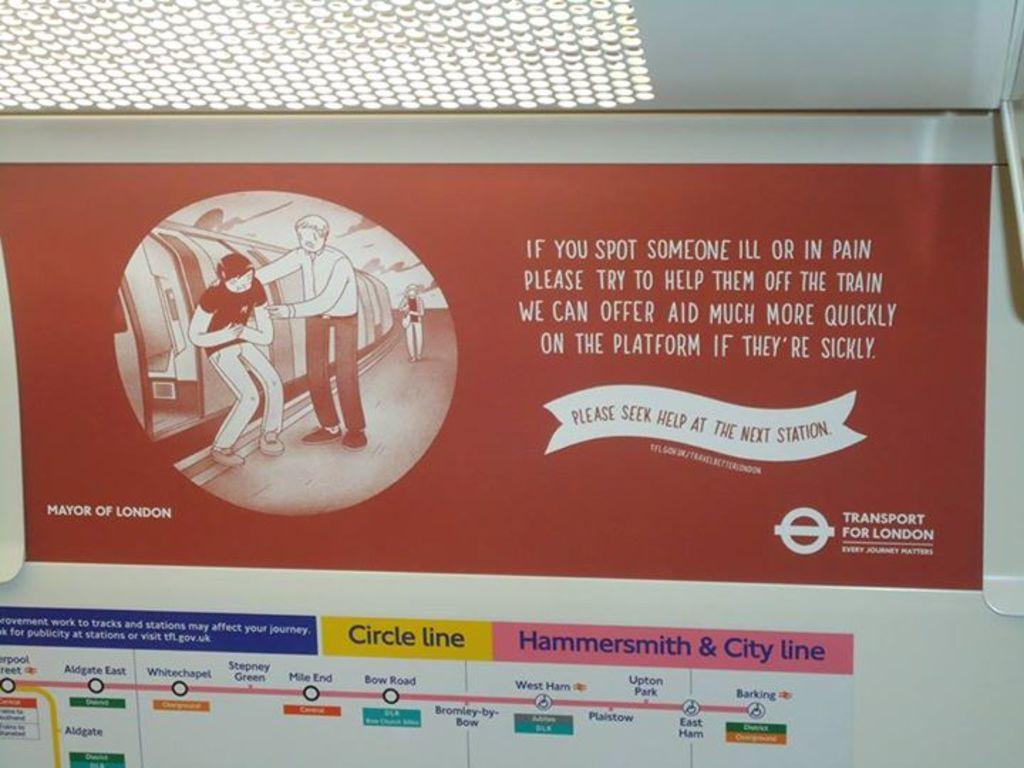What can be seen in the image besides the metal thing? There is a poster in the image. What is the color of the metal thing? The metal thing is white. Where is the metal thing located in the image? The metal thing is in the middle of the image. Is there a throne present in the image? No, there is no throne in the image. Can you describe how the metal thing is connected to the poster? The poster is attached to the metal thing, but the specific method of attachment is not mentioned in the facts. 